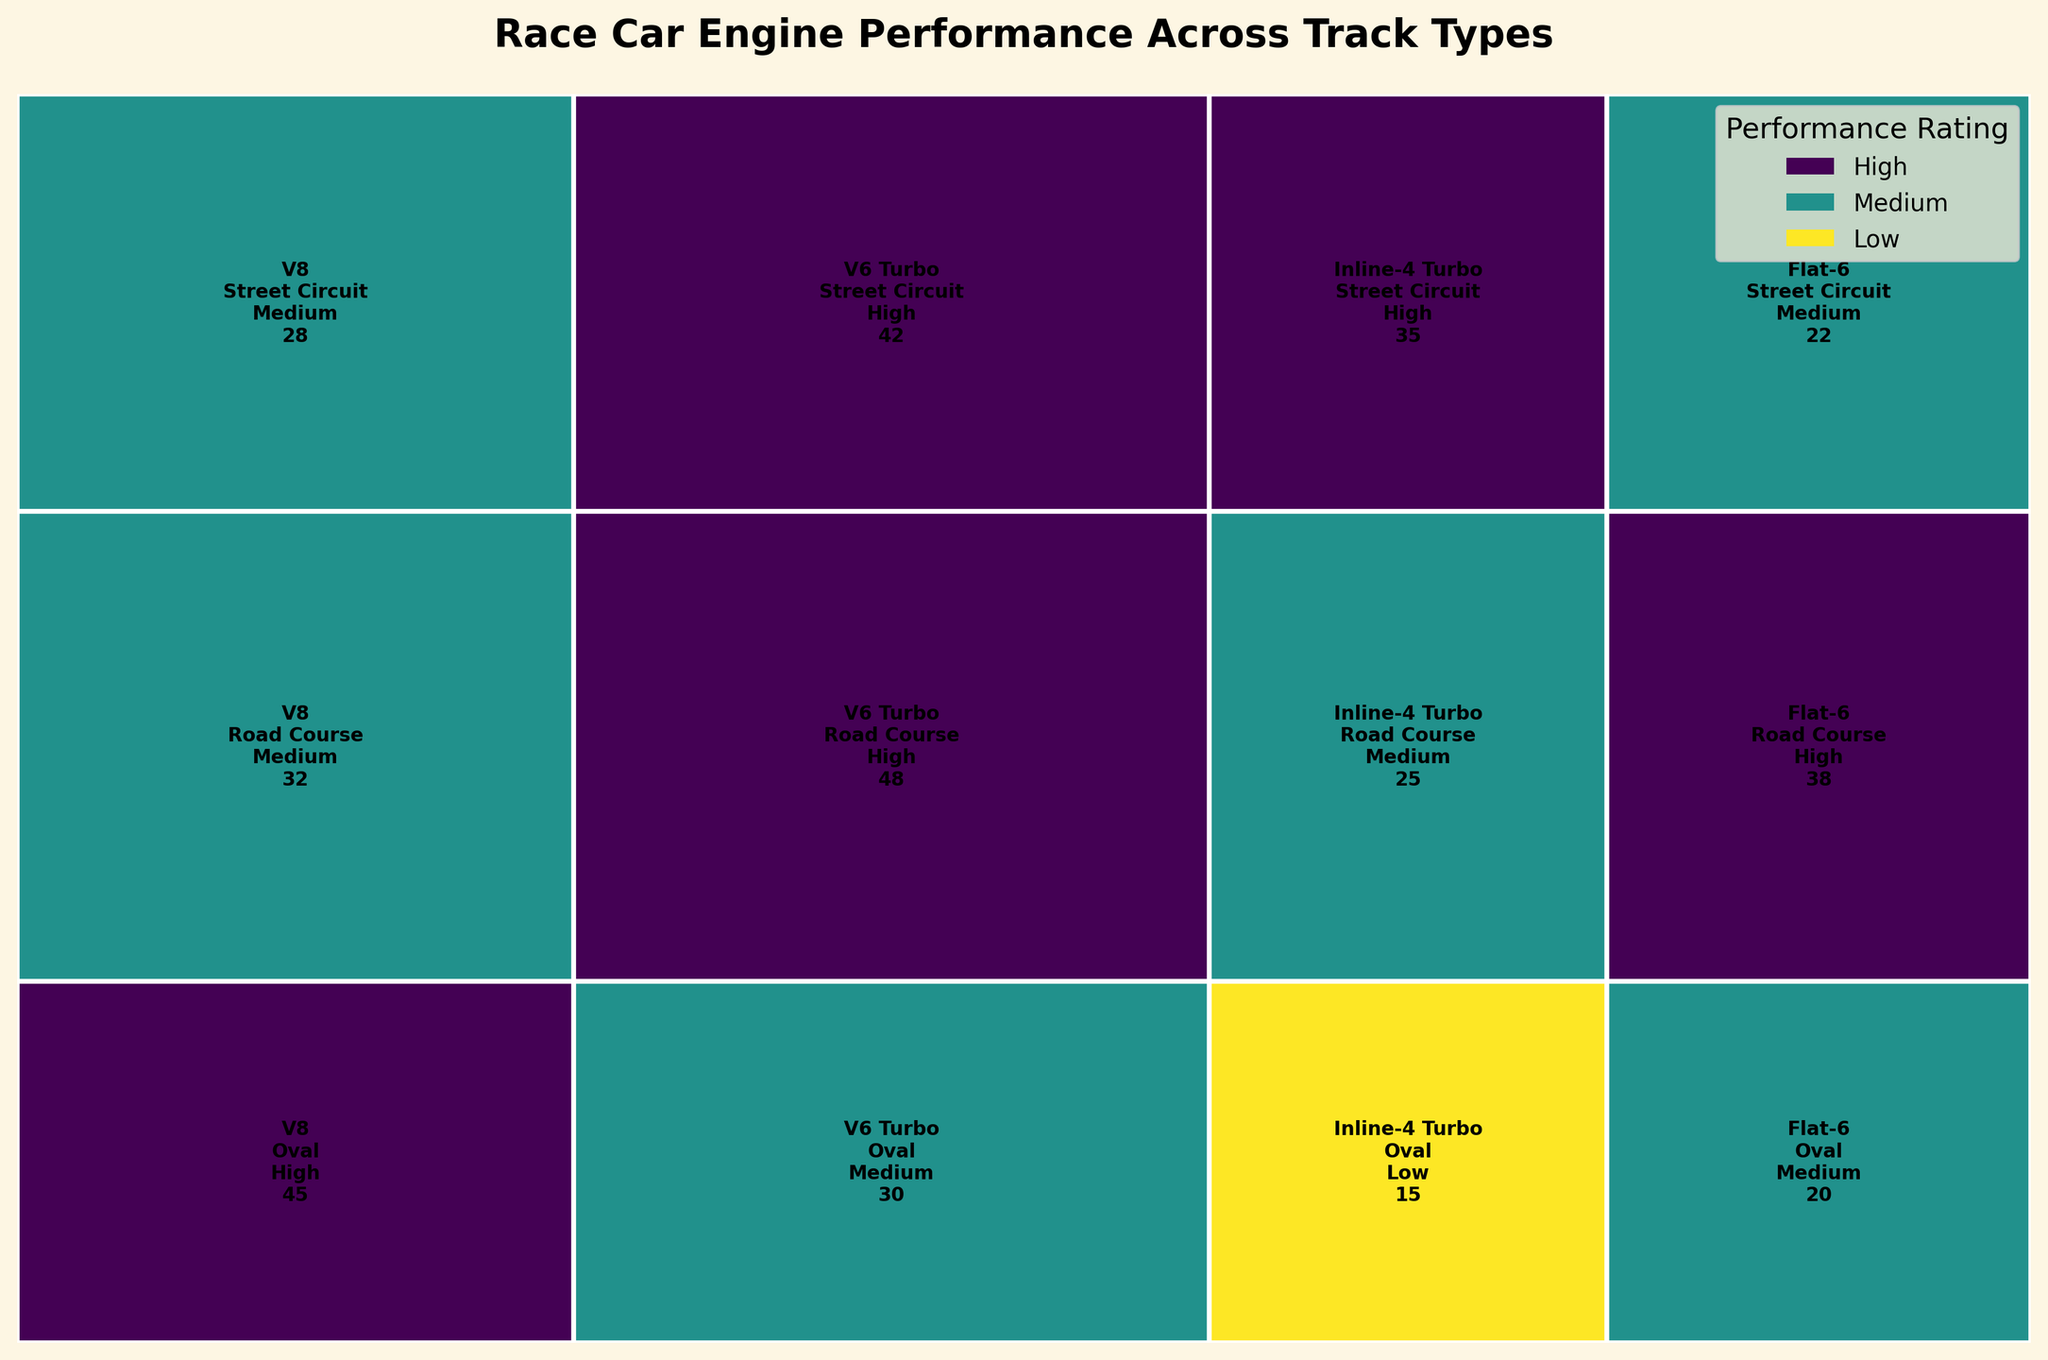Which engine type performs highest overall on road courses? By examining the color and text annotations within the "Road Course" track type section of the mosaic plot, you can identify the performance rating for each engine type. The V6 Turbo and Flat-6 have "High" performance ratings. Comparing their count values, the V6 Turbo has a higher count (48 vs. 38).
Answer: V6 Turbo What is the performance rating of the Inline-4 Turbo on street circuits? Locate the section of the plot that corresponds to the Inline-4 Turbo on street circuits and read the performance rating from the text annotation.
Answer: High How many V8 engines perform at a high level on oval tracks? Identify the V8 section of the plot for oval tracks and check the performance rating listed there. The text annotation shows 45 with a "High" performance rating.
Answer: 45 Is there an engine type that performs only at a medium level across track types? Scan the plot to see if any engine type is annotated with only "Medium" performance in all track types. The V8 has "High," "Medium," and "Medium" for different tracks, so it does not fit this criterion. None fits.
Answer: No, there isn't any Which track type sees the highest total count for the Flat-6 engine? Compare the counts of the Flat-6 engine across oval, road course, and street circuit sections of the plot. Road course has 38, which is higher than the other track types.
Answer: Road Course 